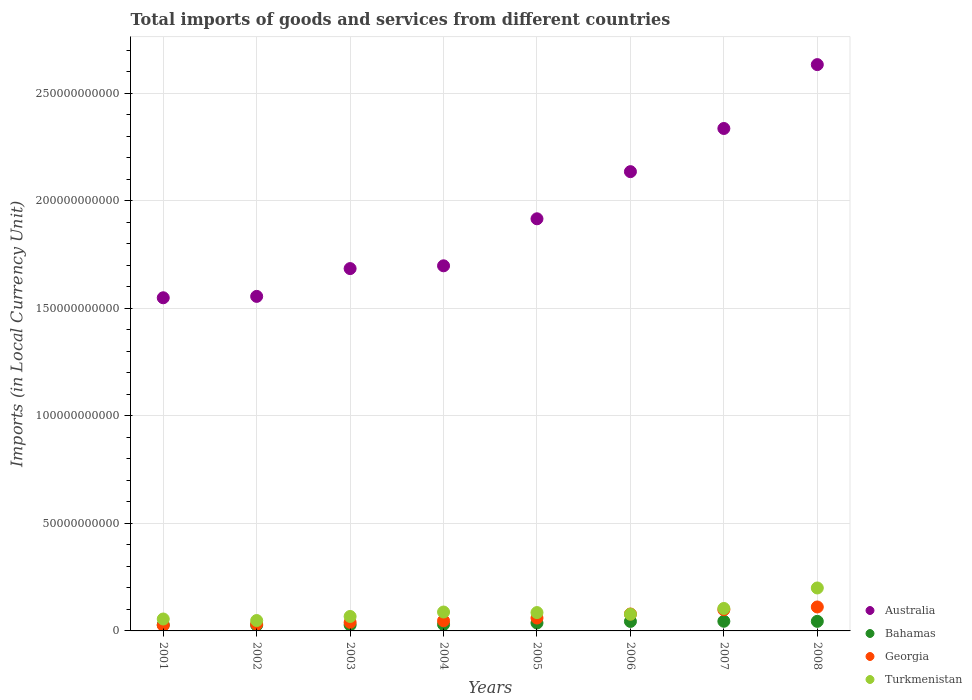What is the Amount of goods and services imports in Georgia in 2005?
Your answer should be very brief. 5.99e+09. Across all years, what is the maximum Amount of goods and services imports in Australia?
Give a very brief answer. 2.63e+11. Across all years, what is the minimum Amount of goods and services imports in Bahamas?
Your answer should be compact. 2.67e+09. In which year was the Amount of goods and services imports in Turkmenistan maximum?
Ensure brevity in your answer.  2008. What is the total Amount of goods and services imports in Georgia in the graph?
Your answer should be very brief. 4.93e+1. What is the difference between the Amount of goods and services imports in Australia in 2004 and that in 2005?
Provide a short and direct response. -2.19e+1. What is the difference between the Amount of goods and services imports in Australia in 2004 and the Amount of goods and services imports in Turkmenistan in 2008?
Your answer should be very brief. 1.50e+11. What is the average Amount of goods and services imports in Bahamas per year?
Offer a terse response. 3.54e+09. In the year 2007, what is the difference between the Amount of goods and services imports in Georgia and Amount of goods and services imports in Turkmenistan?
Ensure brevity in your answer.  -6.01e+08. What is the ratio of the Amount of goods and services imports in Australia in 2005 to that in 2008?
Provide a succinct answer. 0.73. Is the Amount of goods and services imports in Australia in 2002 less than that in 2008?
Keep it short and to the point. Yes. Is the difference between the Amount of goods and services imports in Georgia in 2004 and 2007 greater than the difference between the Amount of goods and services imports in Turkmenistan in 2004 and 2007?
Provide a short and direct response. No. What is the difference between the highest and the second highest Amount of goods and services imports in Bahamas?
Offer a very short reply. 3.76e+07. What is the difference between the highest and the lowest Amount of goods and services imports in Turkmenistan?
Make the answer very short. 1.51e+1. Is the Amount of goods and services imports in Turkmenistan strictly less than the Amount of goods and services imports in Bahamas over the years?
Make the answer very short. No. How many dotlines are there?
Your response must be concise. 4. How many years are there in the graph?
Offer a terse response. 8. Does the graph contain any zero values?
Your answer should be compact. No. Where does the legend appear in the graph?
Offer a terse response. Bottom right. How many legend labels are there?
Provide a short and direct response. 4. What is the title of the graph?
Your answer should be compact. Total imports of goods and services from different countries. What is the label or title of the X-axis?
Offer a terse response. Years. What is the label or title of the Y-axis?
Your answer should be compact. Imports (in Local Currency Unit). What is the Imports (in Local Currency Unit) of Australia in 2001?
Make the answer very short. 1.55e+11. What is the Imports (in Local Currency Unit) of Bahamas in 2001?
Provide a short and direct response. 2.82e+09. What is the Imports (in Local Currency Unit) of Georgia in 2001?
Offer a terse response. 2.59e+09. What is the Imports (in Local Currency Unit) in Turkmenistan in 2001?
Provide a short and direct response. 5.54e+09. What is the Imports (in Local Currency Unit) in Australia in 2002?
Your answer should be compact. 1.56e+11. What is the Imports (in Local Currency Unit) of Bahamas in 2002?
Your answer should be very brief. 2.67e+09. What is the Imports (in Local Currency Unit) of Georgia in 2002?
Provide a succinct answer. 3.16e+09. What is the Imports (in Local Currency Unit) of Turkmenistan in 2002?
Your answer should be compact. 4.83e+09. What is the Imports (in Local Currency Unit) in Australia in 2003?
Ensure brevity in your answer.  1.69e+11. What is the Imports (in Local Currency Unit) in Bahamas in 2003?
Provide a short and direct response. 2.76e+09. What is the Imports (in Local Currency Unit) of Georgia in 2003?
Offer a terse response. 3.98e+09. What is the Imports (in Local Currency Unit) in Turkmenistan in 2003?
Make the answer very short. 6.73e+09. What is the Imports (in Local Currency Unit) in Australia in 2004?
Your response must be concise. 1.70e+11. What is the Imports (in Local Currency Unit) in Bahamas in 2004?
Keep it short and to the point. 3.02e+09. What is the Imports (in Local Currency Unit) of Georgia in 2004?
Your response must be concise. 4.73e+09. What is the Imports (in Local Currency Unit) of Turkmenistan in 2004?
Your answer should be very brief. 8.79e+09. What is the Imports (in Local Currency Unit) in Australia in 2005?
Your response must be concise. 1.92e+11. What is the Imports (in Local Currency Unit) in Bahamas in 2005?
Provide a succinct answer. 3.70e+09. What is the Imports (in Local Currency Unit) in Georgia in 2005?
Your answer should be compact. 5.99e+09. What is the Imports (in Local Currency Unit) of Turkmenistan in 2005?
Offer a very short reply. 8.53e+09. What is the Imports (in Local Currency Unit) in Australia in 2006?
Keep it short and to the point. 2.14e+11. What is the Imports (in Local Currency Unit) in Bahamas in 2006?
Offer a very short reply. 4.42e+09. What is the Imports (in Local Currency Unit) in Georgia in 2006?
Your answer should be very brief. 7.86e+09. What is the Imports (in Local Currency Unit) of Turkmenistan in 2006?
Give a very brief answer. 7.77e+09. What is the Imports (in Local Currency Unit) of Australia in 2007?
Provide a succinct answer. 2.34e+11. What is the Imports (in Local Currency Unit) in Bahamas in 2007?
Provide a succinct answer. 4.49e+09. What is the Imports (in Local Currency Unit) in Georgia in 2007?
Provide a short and direct response. 9.85e+09. What is the Imports (in Local Currency Unit) of Turkmenistan in 2007?
Offer a terse response. 1.04e+1. What is the Imports (in Local Currency Unit) in Australia in 2008?
Your answer should be very brief. 2.63e+11. What is the Imports (in Local Currency Unit) in Bahamas in 2008?
Offer a very short reply. 4.45e+09. What is the Imports (in Local Currency Unit) in Georgia in 2008?
Your answer should be compact. 1.11e+1. What is the Imports (in Local Currency Unit) in Turkmenistan in 2008?
Provide a succinct answer. 2.00e+1. Across all years, what is the maximum Imports (in Local Currency Unit) of Australia?
Ensure brevity in your answer.  2.63e+11. Across all years, what is the maximum Imports (in Local Currency Unit) in Bahamas?
Keep it short and to the point. 4.49e+09. Across all years, what is the maximum Imports (in Local Currency Unit) in Georgia?
Offer a terse response. 1.11e+1. Across all years, what is the maximum Imports (in Local Currency Unit) in Turkmenistan?
Ensure brevity in your answer.  2.00e+1. Across all years, what is the minimum Imports (in Local Currency Unit) of Australia?
Make the answer very short. 1.55e+11. Across all years, what is the minimum Imports (in Local Currency Unit) in Bahamas?
Provide a short and direct response. 2.67e+09. Across all years, what is the minimum Imports (in Local Currency Unit) in Georgia?
Provide a short and direct response. 2.59e+09. Across all years, what is the minimum Imports (in Local Currency Unit) in Turkmenistan?
Your answer should be very brief. 4.83e+09. What is the total Imports (in Local Currency Unit) of Australia in the graph?
Your response must be concise. 1.55e+12. What is the total Imports (in Local Currency Unit) in Bahamas in the graph?
Your answer should be very brief. 2.83e+1. What is the total Imports (in Local Currency Unit) of Georgia in the graph?
Ensure brevity in your answer.  4.93e+1. What is the total Imports (in Local Currency Unit) in Turkmenistan in the graph?
Ensure brevity in your answer.  7.26e+1. What is the difference between the Imports (in Local Currency Unit) in Australia in 2001 and that in 2002?
Your answer should be very brief. -6.45e+08. What is the difference between the Imports (in Local Currency Unit) in Bahamas in 2001 and that in 2002?
Ensure brevity in your answer.  1.48e+08. What is the difference between the Imports (in Local Currency Unit) in Georgia in 2001 and that in 2002?
Provide a short and direct response. -5.67e+08. What is the difference between the Imports (in Local Currency Unit) in Turkmenistan in 2001 and that in 2002?
Make the answer very short. 7.11e+08. What is the difference between the Imports (in Local Currency Unit) of Australia in 2001 and that in 2003?
Provide a succinct answer. -1.36e+1. What is the difference between the Imports (in Local Currency Unit) of Bahamas in 2001 and that in 2003?
Provide a short and direct response. 6.12e+07. What is the difference between the Imports (in Local Currency Unit) in Georgia in 2001 and that in 2003?
Your answer should be compact. -1.38e+09. What is the difference between the Imports (in Local Currency Unit) in Turkmenistan in 2001 and that in 2003?
Give a very brief answer. -1.18e+09. What is the difference between the Imports (in Local Currency Unit) of Australia in 2001 and that in 2004?
Ensure brevity in your answer.  -1.49e+1. What is the difference between the Imports (in Local Currency Unit) of Bahamas in 2001 and that in 2004?
Your response must be concise. -1.99e+08. What is the difference between the Imports (in Local Currency Unit) in Georgia in 2001 and that in 2004?
Your answer should be compact. -2.14e+09. What is the difference between the Imports (in Local Currency Unit) of Turkmenistan in 2001 and that in 2004?
Your response must be concise. -3.25e+09. What is the difference between the Imports (in Local Currency Unit) in Australia in 2001 and that in 2005?
Your response must be concise. -3.67e+1. What is the difference between the Imports (in Local Currency Unit) in Bahamas in 2001 and that in 2005?
Give a very brief answer. -8.80e+08. What is the difference between the Imports (in Local Currency Unit) in Georgia in 2001 and that in 2005?
Keep it short and to the point. -3.40e+09. What is the difference between the Imports (in Local Currency Unit) of Turkmenistan in 2001 and that in 2005?
Your answer should be very brief. -2.99e+09. What is the difference between the Imports (in Local Currency Unit) of Australia in 2001 and that in 2006?
Ensure brevity in your answer.  -5.87e+1. What is the difference between the Imports (in Local Currency Unit) in Bahamas in 2001 and that in 2006?
Offer a very short reply. -1.60e+09. What is the difference between the Imports (in Local Currency Unit) in Georgia in 2001 and that in 2006?
Your response must be concise. -5.27e+09. What is the difference between the Imports (in Local Currency Unit) of Turkmenistan in 2001 and that in 2006?
Your answer should be very brief. -2.23e+09. What is the difference between the Imports (in Local Currency Unit) in Australia in 2001 and that in 2007?
Make the answer very short. -7.87e+1. What is the difference between the Imports (in Local Currency Unit) in Bahamas in 2001 and that in 2007?
Make the answer very short. -1.67e+09. What is the difference between the Imports (in Local Currency Unit) of Georgia in 2001 and that in 2007?
Your response must be concise. -7.25e+09. What is the difference between the Imports (in Local Currency Unit) in Turkmenistan in 2001 and that in 2007?
Offer a very short reply. -4.91e+09. What is the difference between the Imports (in Local Currency Unit) in Australia in 2001 and that in 2008?
Your response must be concise. -1.08e+11. What is the difference between the Imports (in Local Currency Unit) of Bahamas in 2001 and that in 2008?
Offer a very short reply. -1.63e+09. What is the difference between the Imports (in Local Currency Unit) in Georgia in 2001 and that in 2008?
Provide a succinct answer. -8.55e+09. What is the difference between the Imports (in Local Currency Unit) in Turkmenistan in 2001 and that in 2008?
Offer a very short reply. -1.44e+1. What is the difference between the Imports (in Local Currency Unit) in Australia in 2002 and that in 2003?
Your answer should be compact. -1.29e+1. What is the difference between the Imports (in Local Currency Unit) in Bahamas in 2002 and that in 2003?
Provide a short and direct response. -8.67e+07. What is the difference between the Imports (in Local Currency Unit) in Georgia in 2002 and that in 2003?
Make the answer very short. -8.14e+08. What is the difference between the Imports (in Local Currency Unit) in Turkmenistan in 2002 and that in 2003?
Ensure brevity in your answer.  -1.89e+09. What is the difference between the Imports (in Local Currency Unit) of Australia in 2002 and that in 2004?
Your answer should be very brief. -1.42e+1. What is the difference between the Imports (in Local Currency Unit) in Bahamas in 2002 and that in 2004?
Your answer should be very brief. -3.47e+08. What is the difference between the Imports (in Local Currency Unit) in Georgia in 2002 and that in 2004?
Offer a very short reply. -1.57e+09. What is the difference between the Imports (in Local Currency Unit) of Turkmenistan in 2002 and that in 2004?
Ensure brevity in your answer.  -3.96e+09. What is the difference between the Imports (in Local Currency Unit) of Australia in 2002 and that in 2005?
Provide a succinct answer. -3.61e+1. What is the difference between the Imports (in Local Currency Unit) of Bahamas in 2002 and that in 2005?
Your answer should be very brief. -1.03e+09. What is the difference between the Imports (in Local Currency Unit) in Georgia in 2002 and that in 2005?
Give a very brief answer. -2.83e+09. What is the difference between the Imports (in Local Currency Unit) in Turkmenistan in 2002 and that in 2005?
Give a very brief answer. -3.70e+09. What is the difference between the Imports (in Local Currency Unit) in Australia in 2002 and that in 2006?
Offer a very short reply. -5.80e+1. What is the difference between the Imports (in Local Currency Unit) in Bahamas in 2002 and that in 2006?
Provide a succinct answer. -1.74e+09. What is the difference between the Imports (in Local Currency Unit) in Georgia in 2002 and that in 2006?
Ensure brevity in your answer.  -4.70e+09. What is the difference between the Imports (in Local Currency Unit) of Turkmenistan in 2002 and that in 2006?
Provide a succinct answer. -2.94e+09. What is the difference between the Imports (in Local Currency Unit) in Australia in 2002 and that in 2007?
Make the answer very short. -7.81e+1. What is the difference between the Imports (in Local Currency Unit) in Bahamas in 2002 and that in 2007?
Offer a very short reply. -1.82e+09. What is the difference between the Imports (in Local Currency Unit) in Georgia in 2002 and that in 2007?
Your answer should be compact. -6.69e+09. What is the difference between the Imports (in Local Currency Unit) in Turkmenistan in 2002 and that in 2007?
Your response must be concise. -5.62e+09. What is the difference between the Imports (in Local Currency Unit) of Australia in 2002 and that in 2008?
Provide a short and direct response. -1.08e+11. What is the difference between the Imports (in Local Currency Unit) of Bahamas in 2002 and that in 2008?
Keep it short and to the point. -1.78e+09. What is the difference between the Imports (in Local Currency Unit) of Georgia in 2002 and that in 2008?
Your answer should be compact. -7.98e+09. What is the difference between the Imports (in Local Currency Unit) in Turkmenistan in 2002 and that in 2008?
Your answer should be compact. -1.51e+1. What is the difference between the Imports (in Local Currency Unit) in Australia in 2003 and that in 2004?
Offer a terse response. -1.29e+09. What is the difference between the Imports (in Local Currency Unit) in Bahamas in 2003 and that in 2004?
Your response must be concise. -2.60e+08. What is the difference between the Imports (in Local Currency Unit) of Georgia in 2003 and that in 2004?
Keep it short and to the point. -7.58e+08. What is the difference between the Imports (in Local Currency Unit) in Turkmenistan in 2003 and that in 2004?
Ensure brevity in your answer.  -2.06e+09. What is the difference between the Imports (in Local Currency Unit) of Australia in 2003 and that in 2005?
Make the answer very short. -2.32e+1. What is the difference between the Imports (in Local Currency Unit) of Bahamas in 2003 and that in 2005?
Ensure brevity in your answer.  -9.41e+08. What is the difference between the Imports (in Local Currency Unit) of Georgia in 2003 and that in 2005?
Your answer should be compact. -2.02e+09. What is the difference between the Imports (in Local Currency Unit) of Turkmenistan in 2003 and that in 2005?
Make the answer very short. -1.81e+09. What is the difference between the Imports (in Local Currency Unit) of Australia in 2003 and that in 2006?
Make the answer very short. -4.51e+1. What is the difference between the Imports (in Local Currency Unit) in Bahamas in 2003 and that in 2006?
Keep it short and to the point. -1.66e+09. What is the difference between the Imports (in Local Currency Unit) in Georgia in 2003 and that in 2006?
Offer a very short reply. -3.89e+09. What is the difference between the Imports (in Local Currency Unit) of Turkmenistan in 2003 and that in 2006?
Offer a terse response. -1.04e+09. What is the difference between the Imports (in Local Currency Unit) of Australia in 2003 and that in 2007?
Make the answer very short. -6.52e+1. What is the difference between the Imports (in Local Currency Unit) of Bahamas in 2003 and that in 2007?
Your response must be concise. -1.73e+09. What is the difference between the Imports (in Local Currency Unit) of Georgia in 2003 and that in 2007?
Give a very brief answer. -5.87e+09. What is the difference between the Imports (in Local Currency Unit) in Turkmenistan in 2003 and that in 2007?
Your response must be concise. -3.72e+09. What is the difference between the Imports (in Local Currency Unit) of Australia in 2003 and that in 2008?
Offer a very short reply. -9.49e+1. What is the difference between the Imports (in Local Currency Unit) of Bahamas in 2003 and that in 2008?
Ensure brevity in your answer.  -1.69e+09. What is the difference between the Imports (in Local Currency Unit) of Georgia in 2003 and that in 2008?
Offer a terse response. -7.16e+09. What is the difference between the Imports (in Local Currency Unit) in Turkmenistan in 2003 and that in 2008?
Your answer should be very brief. -1.32e+1. What is the difference between the Imports (in Local Currency Unit) of Australia in 2004 and that in 2005?
Make the answer very short. -2.19e+1. What is the difference between the Imports (in Local Currency Unit) in Bahamas in 2004 and that in 2005?
Ensure brevity in your answer.  -6.81e+08. What is the difference between the Imports (in Local Currency Unit) in Georgia in 2004 and that in 2005?
Ensure brevity in your answer.  -1.26e+09. What is the difference between the Imports (in Local Currency Unit) of Turkmenistan in 2004 and that in 2005?
Ensure brevity in your answer.  2.55e+08. What is the difference between the Imports (in Local Currency Unit) in Australia in 2004 and that in 2006?
Your answer should be very brief. -4.38e+1. What is the difference between the Imports (in Local Currency Unit) in Bahamas in 2004 and that in 2006?
Offer a very short reply. -1.40e+09. What is the difference between the Imports (in Local Currency Unit) of Georgia in 2004 and that in 2006?
Offer a very short reply. -3.13e+09. What is the difference between the Imports (in Local Currency Unit) in Turkmenistan in 2004 and that in 2006?
Ensure brevity in your answer.  1.02e+09. What is the difference between the Imports (in Local Currency Unit) of Australia in 2004 and that in 2007?
Ensure brevity in your answer.  -6.39e+1. What is the difference between the Imports (in Local Currency Unit) in Bahamas in 2004 and that in 2007?
Your answer should be compact. -1.47e+09. What is the difference between the Imports (in Local Currency Unit) in Georgia in 2004 and that in 2007?
Keep it short and to the point. -5.11e+09. What is the difference between the Imports (in Local Currency Unit) of Turkmenistan in 2004 and that in 2007?
Offer a very short reply. -1.66e+09. What is the difference between the Imports (in Local Currency Unit) in Australia in 2004 and that in 2008?
Your answer should be compact. -9.36e+1. What is the difference between the Imports (in Local Currency Unit) of Bahamas in 2004 and that in 2008?
Keep it short and to the point. -1.43e+09. What is the difference between the Imports (in Local Currency Unit) of Georgia in 2004 and that in 2008?
Offer a very short reply. -6.41e+09. What is the difference between the Imports (in Local Currency Unit) in Turkmenistan in 2004 and that in 2008?
Provide a short and direct response. -1.12e+1. What is the difference between the Imports (in Local Currency Unit) in Australia in 2005 and that in 2006?
Keep it short and to the point. -2.19e+1. What is the difference between the Imports (in Local Currency Unit) in Bahamas in 2005 and that in 2006?
Ensure brevity in your answer.  -7.17e+08. What is the difference between the Imports (in Local Currency Unit) of Georgia in 2005 and that in 2006?
Give a very brief answer. -1.87e+09. What is the difference between the Imports (in Local Currency Unit) in Turkmenistan in 2005 and that in 2006?
Your answer should be compact. 7.64e+08. What is the difference between the Imports (in Local Currency Unit) of Australia in 2005 and that in 2007?
Provide a short and direct response. -4.20e+1. What is the difference between the Imports (in Local Currency Unit) of Bahamas in 2005 and that in 2007?
Provide a succinct answer. -7.89e+08. What is the difference between the Imports (in Local Currency Unit) in Georgia in 2005 and that in 2007?
Your answer should be compact. -3.86e+09. What is the difference between the Imports (in Local Currency Unit) in Turkmenistan in 2005 and that in 2007?
Ensure brevity in your answer.  -1.92e+09. What is the difference between the Imports (in Local Currency Unit) in Australia in 2005 and that in 2008?
Offer a very short reply. -7.17e+1. What is the difference between the Imports (in Local Currency Unit) in Bahamas in 2005 and that in 2008?
Your response must be concise. -7.52e+08. What is the difference between the Imports (in Local Currency Unit) in Georgia in 2005 and that in 2008?
Keep it short and to the point. -5.15e+09. What is the difference between the Imports (in Local Currency Unit) of Turkmenistan in 2005 and that in 2008?
Your answer should be compact. -1.14e+1. What is the difference between the Imports (in Local Currency Unit) in Australia in 2006 and that in 2007?
Your response must be concise. -2.01e+1. What is the difference between the Imports (in Local Currency Unit) in Bahamas in 2006 and that in 2007?
Make the answer very short. -7.22e+07. What is the difference between the Imports (in Local Currency Unit) in Georgia in 2006 and that in 2007?
Your answer should be compact. -1.99e+09. What is the difference between the Imports (in Local Currency Unit) in Turkmenistan in 2006 and that in 2007?
Make the answer very short. -2.68e+09. What is the difference between the Imports (in Local Currency Unit) in Australia in 2006 and that in 2008?
Give a very brief answer. -4.98e+1. What is the difference between the Imports (in Local Currency Unit) in Bahamas in 2006 and that in 2008?
Provide a succinct answer. -3.46e+07. What is the difference between the Imports (in Local Currency Unit) in Georgia in 2006 and that in 2008?
Give a very brief answer. -3.28e+09. What is the difference between the Imports (in Local Currency Unit) of Turkmenistan in 2006 and that in 2008?
Your answer should be compact. -1.22e+1. What is the difference between the Imports (in Local Currency Unit) of Australia in 2007 and that in 2008?
Provide a succinct answer. -2.97e+1. What is the difference between the Imports (in Local Currency Unit) of Bahamas in 2007 and that in 2008?
Your answer should be compact. 3.76e+07. What is the difference between the Imports (in Local Currency Unit) of Georgia in 2007 and that in 2008?
Keep it short and to the point. -1.29e+09. What is the difference between the Imports (in Local Currency Unit) of Turkmenistan in 2007 and that in 2008?
Your answer should be compact. -9.52e+09. What is the difference between the Imports (in Local Currency Unit) in Australia in 2001 and the Imports (in Local Currency Unit) in Bahamas in 2002?
Keep it short and to the point. 1.52e+11. What is the difference between the Imports (in Local Currency Unit) of Australia in 2001 and the Imports (in Local Currency Unit) of Georgia in 2002?
Your answer should be very brief. 1.52e+11. What is the difference between the Imports (in Local Currency Unit) in Australia in 2001 and the Imports (in Local Currency Unit) in Turkmenistan in 2002?
Offer a very short reply. 1.50e+11. What is the difference between the Imports (in Local Currency Unit) of Bahamas in 2001 and the Imports (in Local Currency Unit) of Georgia in 2002?
Give a very brief answer. -3.41e+08. What is the difference between the Imports (in Local Currency Unit) in Bahamas in 2001 and the Imports (in Local Currency Unit) in Turkmenistan in 2002?
Your answer should be compact. -2.01e+09. What is the difference between the Imports (in Local Currency Unit) of Georgia in 2001 and the Imports (in Local Currency Unit) of Turkmenistan in 2002?
Offer a terse response. -2.24e+09. What is the difference between the Imports (in Local Currency Unit) of Australia in 2001 and the Imports (in Local Currency Unit) of Bahamas in 2003?
Your answer should be compact. 1.52e+11. What is the difference between the Imports (in Local Currency Unit) in Australia in 2001 and the Imports (in Local Currency Unit) in Georgia in 2003?
Ensure brevity in your answer.  1.51e+11. What is the difference between the Imports (in Local Currency Unit) of Australia in 2001 and the Imports (in Local Currency Unit) of Turkmenistan in 2003?
Provide a short and direct response. 1.48e+11. What is the difference between the Imports (in Local Currency Unit) of Bahamas in 2001 and the Imports (in Local Currency Unit) of Georgia in 2003?
Keep it short and to the point. -1.16e+09. What is the difference between the Imports (in Local Currency Unit) in Bahamas in 2001 and the Imports (in Local Currency Unit) in Turkmenistan in 2003?
Your answer should be compact. -3.91e+09. What is the difference between the Imports (in Local Currency Unit) of Georgia in 2001 and the Imports (in Local Currency Unit) of Turkmenistan in 2003?
Give a very brief answer. -4.13e+09. What is the difference between the Imports (in Local Currency Unit) of Australia in 2001 and the Imports (in Local Currency Unit) of Bahamas in 2004?
Your response must be concise. 1.52e+11. What is the difference between the Imports (in Local Currency Unit) in Australia in 2001 and the Imports (in Local Currency Unit) in Georgia in 2004?
Your answer should be compact. 1.50e+11. What is the difference between the Imports (in Local Currency Unit) in Australia in 2001 and the Imports (in Local Currency Unit) in Turkmenistan in 2004?
Your answer should be very brief. 1.46e+11. What is the difference between the Imports (in Local Currency Unit) in Bahamas in 2001 and the Imports (in Local Currency Unit) in Georgia in 2004?
Make the answer very short. -1.91e+09. What is the difference between the Imports (in Local Currency Unit) of Bahamas in 2001 and the Imports (in Local Currency Unit) of Turkmenistan in 2004?
Provide a short and direct response. -5.97e+09. What is the difference between the Imports (in Local Currency Unit) of Georgia in 2001 and the Imports (in Local Currency Unit) of Turkmenistan in 2004?
Keep it short and to the point. -6.20e+09. What is the difference between the Imports (in Local Currency Unit) of Australia in 2001 and the Imports (in Local Currency Unit) of Bahamas in 2005?
Keep it short and to the point. 1.51e+11. What is the difference between the Imports (in Local Currency Unit) of Australia in 2001 and the Imports (in Local Currency Unit) of Georgia in 2005?
Make the answer very short. 1.49e+11. What is the difference between the Imports (in Local Currency Unit) of Australia in 2001 and the Imports (in Local Currency Unit) of Turkmenistan in 2005?
Keep it short and to the point. 1.46e+11. What is the difference between the Imports (in Local Currency Unit) of Bahamas in 2001 and the Imports (in Local Currency Unit) of Georgia in 2005?
Make the answer very short. -3.17e+09. What is the difference between the Imports (in Local Currency Unit) of Bahamas in 2001 and the Imports (in Local Currency Unit) of Turkmenistan in 2005?
Provide a succinct answer. -5.71e+09. What is the difference between the Imports (in Local Currency Unit) of Georgia in 2001 and the Imports (in Local Currency Unit) of Turkmenistan in 2005?
Make the answer very short. -5.94e+09. What is the difference between the Imports (in Local Currency Unit) of Australia in 2001 and the Imports (in Local Currency Unit) of Bahamas in 2006?
Your answer should be compact. 1.51e+11. What is the difference between the Imports (in Local Currency Unit) in Australia in 2001 and the Imports (in Local Currency Unit) in Georgia in 2006?
Provide a succinct answer. 1.47e+11. What is the difference between the Imports (in Local Currency Unit) of Australia in 2001 and the Imports (in Local Currency Unit) of Turkmenistan in 2006?
Your answer should be very brief. 1.47e+11. What is the difference between the Imports (in Local Currency Unit) of Bahamas in 2001 and the Imports (in Local Currency Unit) of Georgia in 2006?
Keep it short and to the point. -5.04e+09. What is the difference between the Imports (in Local Currency Unit) of Bahamas in 2001 and the Imports (in Local Currency Unit) of Turkmenistan in 2006?
Your answer should be compact. -4.95e+09. What is the difference between the Imports (in Local Currency Unit) in Georgia in 2001 and the Imports (in Local Currency Unit) in Turkmenistan in 2006?
Your response must be concise. -5.18e+09. What is the difference between the Imports (in Local Currency Unit) in Australia in 2001 and the Imports (in Local Currency Unit) in Bahamas in 2007?
Give a very brief answer. 1.50e+11. What is the difference between the Imports (in Local Currency Unit) of Australia in 2001 and the Imports (in Local Currency Unit) of Georgia in 2007?
Provide a succinct answer. 1.45e+11. What is the difference between the Imports (in Local Currency Unit) of Australia in 2001 and the Imports (in Local Currency Unit) of Turkmenistan in 2007?
Your response must be concise. 1.44e+11. What is the difference between the Imports (in Local Currency Unit) in Bahamas in 2001 and the Imports (in Local Currency Unit) in Georgia in 2007?
Offer a very short reply. -7.03e+09. What is the difference between the Imports (in Local Currency Unit) in Bahamas in 2001 and the Imports (in Local Currency Unit) in Turkmenistan in 2007?
Your response must be concise. -7.63e+09. What is the difference between the Imports (in Local Currency Unit) in Georgia in 2001 and the Imports (in Local Currency Unit) in Turkmenistan in 2007?
Offer a terse response. -7.85e+09. What is the difference between the Imports (in Local Currency Unit) of Australia in 2001 and the Imports (in Local Currency Unit) of Bahamas in 2008?
Provide a succinct answer. 1.50e+11. What is the difference between the Imports (in Local Currency Unit) in Australia in 2001 and the Imports (in Local Currency Unit) in Georgia in 2008?
Keep it short and to the point. 1.44e+11. What is the difference between the Imports (in Local Currency Unit) of Australia in 2001 and the Imports (in Local Currency Unit) of Turkmenistan in 2008?
Offer a terse response. 1.35e+11. What is the difference between the Imports (in Local Currency Unit) in Bahamas in 2001 and the Imports (in Local Currency Unit) in Georgia in 2008?
Ensure brevity in your answer.  -8.32e+09. What is the difference between the Imports (in Local Currency Unit) in Bahamas in 2001 and the Imports (in Local Currency Unit) in Turkmenistan in 2008?
Make the answer very short. -1.72e+1. What is the difference between the Imports (in Local Currency Unit) in Georgia in 2001 and the Imports (in Local Currency Unit) in Turkmenistan in 2008?
Ensure brevity in your answer.  -1.74e+1. What is the difference between the Imports (in Local Currency Unit) in Australia in 2002 and the Imports (in Local Currency Unit) in Bahamas in 2003?
Make the answer very short. 1.53e+11. What is the difference between the Imports (in Local Currency Unit) in Australia in 2002 and the Imports (in Local Currency Unit) in Georgia in 2003?
Your answer should be compact. 1.52e+11. What is the difference between the Imports (in Local Currency Unit) of Australia in 2002 and the Imports (in Local Currency Unit) of Turkmenistan in 2003?
Your response must be concise. 1.49e+11. What is the difference between the Imports (in Local Currency Unit) in Bahamas in 2002 and the Imports (in Local Currency Unit) in Georgia in 2003?
Give a very brief answer. -1.30e+09. What is the difference between the Imports (in Local Currency Unit) of Bahamas in 2002 and the Imports (in Local Currency Unit) of Turkmenistan in 2003?
Make the answer very short. -4.05e+09. What is the difference between the Imports (in Local Currency Unit) in Georgia in 2002 and the Imports (in Local Currency Unit) in Turkmenistan in 2003?
Offer a terse response. -3.56e+09. What is the difference between the Imports (in Local Currency Unit) of Australia in 2002 and the Imports (in Local Currency Unit) of Bahamas in 2004?
Provide a short and direct response. 1.53e+11. What is the difference between the Imports (in Local Currency Unit) of Australia in 2002 and the Imports (in Local Currency Unit) of Georgia in 2004?
Your answer should be compact. 1.51e+11. What is the difference between the Imports (in Local Currency Unit) of Australia in 2002 and the Imports (in Local Currency Unit) of Turkmenistan in 2004?
Give a very brief answer. 1.47e+11. What is the difference between the Imports (in Local Currency Unit) in Bahamas in 2002 and the Imports (in Local Currency Unit) in Georgia in 2004?
Provide a succinct answer. -2.06e+09. What is the difference between the Imports (in Local Currency Unit) of Bahamas in 2002 and the Imports (in Local Currency Unit) of Turkmenistan in 2004?
Provide a short and direct response. -6.12e+09. What is the difference between the Imports (in Local Currency Unit) of Georgia in 2002 and the Imports (in Local Currency Unit) of Turkmenistan in 2004?
Give a very brief answer. -5.63e+09. What is the difference between the Imports (in Local Currency Unit) of Australia in 2002 and the Imports (in Local Currency Unit) of Bahamas in 2005?
Keep it short and to the point. 1.52e+11. What is the difference between the Imports (in Local Currency Unit) of Australia in 2002 and the Imports (in Local Currency Unit) of Georgia in 2005?
Your answer should be very brief. 1.50e+11. What is the difference between the Imports (in Local Currency Unit) in Australia in 2002 and the Imports (in Local Currency Unit) in Turkmenistan in 2005?
Make the answer very short. 1.47e+11. What is the difference between the Imports (in Local Currency Unit) of Bahamas in 2002 and the Imports (in Local Currency Unit) of Georgia in 2005?
Offer a terse response. -3.32e+09. What is the difference between the Imports (in Local Currency Unit) of Bahamas in 2002 and the Imports (in Local Currency Unit) of Turkmenistan in 2005?
Your response must be concise. -5.86e+09. What is the difference between the Imports (in Local Currency Unit) in Georgia in 2002 and the Imports (in Local Currency Unit) in Turkmenistan in 2005?
Provide a short and direct response. -5.37e+09. What is the difference between the Imports (in Local Currency Unit) of Australia in 2002 and the Imports (in Local Currency Unit) of Bahamas in 2006?
Keep it short and to the point. 1.51e+11. What is the difference between the Imports (in Local Currency Unit) of Australia in 2002 and the Imports (in Local Currency Unit) of Georgia in 2006?
Give a very brief answer. 1.48e+11. What is the difference between the Imports (in Local Currency Unit) in Australia in 2002 and the Imports (in Local Currency Unit) in Turkmenistan in 2006?
Keep it short and to the point. 1.48e+11. What is the difference between the Imports (in Local Currency Unit) in Bahamas in 2002 and the Imports (in Local Currency Unit) in Georgia in 2006?
Offer a terse response. -5.19e+09. What is the difference between the Imports (in Local Currency Unit) in Bahamas in 2002 and the Imports (in Local Currency Unit) in Turkmenistan in 2006?
Offer a very short reply. -5.10e+09. What is the difference between the Imports (in Local Currency Unit) of Georgia in 2002 and the Imports (in Local Currency Unit) of Turkmenistan in 2006?
Ensure brevity in your answer.  -4.61e+09. What is the difference between the Imports (in Local Currency Unit) of Australia in 2002 and the Imports (in Local Currency Unit) of Bahamas in 2007?
Offer a very short reply. 1.51e+11. What is the difference between the Imports (in Local Currency Unit) in Australia in 2002 and the Imports (in Local Currency Unit) in Georgia in 2007?
Offer a very short reply. 1.46e+11. What is the difference between the Imports (in Local Currency Unit) in Australia in 2002 and the Imports (in Local Currency Unit) in Turkmenistan in 2007?
Give a very brief answer. 1.45e+11. What is the difference between the Imports (in Local Currency Unit) in Bahamas in 2002 and the Imports (in Local Currency Unit) in Georgia in 2007?
Ensure brevity in your answer.  -7.18e+09. What is the difference between the Imports (in Local Currency Unit) in Bahamas in 2002 and the Imports (in Local Currency Unit) in Turkmenistan in 2007?
Ensure brevity in your answer.  -7.78e+09. What is the difference between the Imports (in Local Currency Unit) of Georgia in 2002 and the Imports (in Local Currency Unit) of Turkmenistan in 2007?
Make the answer very short. -7.29e+09. What is the difference between the Imports (in Local Currency Unit) in Australia in 2002 and the Imports (in Local Currency Unit) in Bahamas in 2008?
Provide a succinct answer. 1.51e+11. What is the difference between the Imports (in Local Currency Unit) of Australia in 2002 and the Imports (in Local Currency Unit) of Georgia in 2008?
Offer a terse response. 1.44e+11. What is the difference between the Imports (in Local Currency Unit) in Australia in 2002 and the Imports (in Local Currency Unit) in Turkmenistan in 2008?
Provide a succinct answer. 1.36e+11. What is the difference between the Imports (in Local Currency Unit) in Bahamas in 2002 and the Imports (in Local Currency Unit) in Georgia in 2008?
Give a very brief answer. -8.47e+09. What is the difference between the Imports (in Local Currency Unit) of Bahamas in 2002 and the Imports (in Local Currency Unit) of Turkmenistan in 2008?
Offer a terse response. -1.73e+1. What is the difference between the Imports (in Local Currency Unit) of Georgia in 2002 and the Imports (in Local Currency Unit) of Turkmenistan in 2008?
Provide a succinct answer. -1.68e+1. What is the difference between the Imports (in Local Currency Unit) in Australia in 2003 and the Imports (in Local Currency Unit) in Bahamas in 2004?
Your answer should be very brief. 1.65e+11. What is the difference between the Imports (in Local Currency Unit) in Australia in 2003 and the Imports (in Local Currency Unit) in Georgia in 2004?
Ensure brevity in your answer.  1.64e+11. What is the difference between the Imports (in Local Currency Unit) of Australia in 2003 and the Imports (in Local Currency Unit) of Turkmenistan in 2004?
Offer a very short reply. 1.60e+11. What is the difference between the Imports (in Local Currency Unit) in Bahamas in 2003 and the Imports (in Local Currency Unit) in Georgia in 2004?
Make the answer very short. -1.97e+09. What is the difference between the Imports (in Local Currency Unit) of Bahamas in 2003 and the Imports (in Local Currency Unit) of Turkmenistan in 2004?
Offer a very short reply. -6.03e+09. What is the difference between the Imports (in Local Currency Unit) in Georgia in 2003 and the Imports (in Local Currency Unit) in Turkmenistan in 2004?
Your response must be concise. -4.81e+09. What is the difference between the Imports (in Local Currency Unit) of Australia in 2003 and the Imports (in Local Currency Unit) of Bahamas in 2005?
Provide a succinct answer. 1.65e+11. What is the difference between the Imports (in Local Currency Unit) in Australia in 2003 and the Imports (in Local Currency Unit) in Georgia in 2005?
Make the answer very short. 1.63e+11. What is the difference between the Imports (in Local Currency Unit) in Australia in 2003 and the Imports (in Local Currency Unit) in Turkmenistan in 2005?
Provide a short and direct response. 1.60e+11. What is the difference between the Imports (in Local Currency Unit) in Bahamas in 2003 and the Imports (in Local Currency Unit) in Georgia in 2005?
Offer a very short reply. -3.23e+09. What is the difference between the Imports (in Local Currency Unit) in Bahamas in 2003 and the Imports (in Local Currency Unit) in Turkmenistan in 2005?
Provide a succinct answer. -5.78e+09. What is the difference between the Imports (in Local Currency Unit) of Georgia in 2003 and the Imports (in Local Currency Unit) of Turkmenistan in 2005?
Make the answer very short. -4.56e+09. What is the difference between the Imports (in Local Currency Unit) of Australia in 2003 and the Imports (in Local Currency Unit) of Bahamas in 2006?
Keep it short and to the point. 1.64e+11. What is the difference between the Imports (in Local Currency Unit) of Australia in 2003 and the Imports (in Local Currency Unit) of Georgia in 2006?
Offer a terse response. 1.61e+11. What is the difference between the Imports (in Local Currency Unit) of Australia in 2003 and the Imports (in Local Currency Unit) of Turkmenistan in 2006?
Provide a succinct answer. 1.61e+11. What is the difference between the Imports (in Local Currency Unit) in Bahamas in 2003 and the Imports (in Local Currency Unit) in Georgia in 2006?
Ensure brevity in your answer.  -5.10e+09. What is the difference between the Imports (in Local Currency Unit) in Bahamas in 2003 and the Imports (in Local Currency Unit) in Turkmenistan in 2006?
Ensure brevity in your answer.  -5.01e+09. What is the difference between the Imports (in Local Currency Unit) in Georgia in 2003 and the Imports (in Local Currency Unit) in Turkmenistan in 2006?
Give a very brief answer. -3.79e+09. What is the difference between the Imports (in Local Currency Unit) of Australia in 2003 and the Imports (in Local Currency Unit) of Bahamas in 2007?
Provide a succinct answer. 1.64e+11. What is the difference between the Imports (in Local Currency Unit) in Australia in 2003 and the Imports (in Local Currency Unit) in Georgia in 2007?
Give a very brief answer. 1.59e+11. What is the difference between the Imports (in Local Currency Unit) in Australia in 2003 and the Imports (in Local Currency Unit) in Turkmenistan in 2007?
Provide a succinct answer. 1.58e+11. What is the difference between the Imports (in Local Currency Unit) of Bahamas in 2003 and the Imports (in Local Currency Unit) of Georgia in 2007?
Make the answer very short. -7.09e+09. What is the difference between the Imports (in Local Currency Unit) of Bahamas in 2003 and the Imports (in Local Currency Unit) of Turkmenistan in 2007?
Offer a terse response. -7.69e+09. What is the difference between the Imports (in Local Currency Unit) of Georgia in 2003 and the Imports (in Local Currency Unit) of Turkmenistan in 2007?
Give a very brief answer. -6.47e+09. What is the difference between the Imports (in Local Currency Unit) in Australia in 2003 and the Imports (in Local Currency Unit) in Bahamas in 2008?
Offer a terse response. 1.64e+11. What is the difference between the Imports (in Local Currency Unit) in Australia in 2003 and the Imports (in Local Currency Unit) in Georgia in 2008?
Give a very brief answer. 1.57e+11. What is the difference between the Imports (in Local Currency Unit) of Australia in 2003 and the Imports (in Local Currency Unit) of Turkmenistan in 2008?
Make the answer very short. 1.49e+11. What is the difference between the Imports (in Local Currency Unit) of Bahamas in 2003 and the Imports (in Local Currency Unit) of Georgia in 2008?
Offer a very short reply. -8.38e+09. What is the difference between the Imports (in Local Currency Unit) in Bahamas in 2003 and the Imports (in Local Currency Unit) in Turkmenistan in 2008?
Offer a terse response. -1.72e+1. What is the difference between the Imports (in Local Currency Unit) of Georgia in 2003 and the Imports (in Local Currency Unit) of Turkmenistan in 2008?
Offer a terse response. -1.60e+1. What is the difference between the Imports (in Local Currency Unit) in Australia in 2004 and the Imports (in Local Currency Unit) in Bahamas in 2005?
Your response must be concise. 1.66e+11. What is the difference between the Imports (in Local Currency Unit) in Australia in 2004 and the Imports (in Local Currency Unit) in Georgia in 2005?
Make the answer very short. 1.64e+11. What is the difference between the Imports (in Local Currency Unit) in Australia in 2004 and the Imports (in Local Currency Unit) in Turkmenistan in 2005?
Provide a succinct answer. 1.61e+11. What is the difference between the Imports (in Local Currency Unit) of Bahamas in 2004 and the Imports (in Local Currency Unit) of Georgia in 2005?
Ensure brevity in your answer.  -2.97e+09. What is the difference between the Imports (in Local Currency Unit) in Bahamas in 2004 and the Imports (in Local Currency Unit) in Turkmenistan in 2005?
Give a very brief answer. -5.51e+09. What is the difference between the Imports (in Local Currency Unit) in Georgia in 2004 and the Imports (in Local Currency Unit) in Turkmenistan in 2005?
Your answer should be compact. -3.80e+09. What is the difference between the Imports (in Local Currency Unit) in Australia in 2004 and the Imports (in Local Currency Unit) in Bahamas in 2006?
Ensure brevity in your answer.  1.65e+11. What is the difference between the Imports (in Local Currency Unit) of Australia in 2004 and the Imports (in Local Currency Unit) of Georgia in 2006?
Give a very brief answer. 1.62e+11. What is the difference between the Imports (in Local Currency Unit) of Australia in 2004 and the Imports (in Local Currency Unit) of Turkmenistan in 2006?
Your answer should be compact. 1.62e+11. What is the difference between the Imports (in Local Currency Unit) of Bahamas in 2004 and the Imports (in Local Currency Unit) of Georgia in 2006?
Your answer should be compact. -4.84e+09. What is the difference between the Imports (in Local Currency Unit) of Bahamas in 2004 and the Imports (in Local Currency Unit) of Turkmenistan in 2006?
Provide a short and direct response. -4.75e+09. What is the difference between the Imports (in Local Currency Unit) of Georgia in 2004 and the Imports (in Local Currency Unit) of Turkmenistan in 2006?
Make the answer very short. -3.04e+09. What is the difference between the Imports (in Local Currency Unit) in Australia in 2004 and the Imports (in Local Currency Unit) in Bahamas in 2007?
Provide a short and direct response. 1.65e+11. What is the difference between the Imports (in Local Currency Unit) of Australia in 2004 and the Imports (in Local Currency Unit) of Georgia in 2007?
Offer a terse response. 1.60e+11. What is the difference between the Imports (in Local Currency Unit) in Australia in 2004 and the Imports (in Local Currency Unit) in Turkmenistan in 2007?
Ensure brevity in your answer.  1.59e+11. What is the difference between the Imports (in Local Currency Unit) in Bahamas in 2004 and the Imports (in Local Currency Unit) in Georgia in 2007?
Ensure brevity in your answer.  -6.83e+09. What is the difference between the Imports (in Local Currency Unit) of Bahamas in 2004 and the Imports (in Local Currency Unit) of Turkmenistan in 2007?
Make the answer very short. -7.43e+09. What is the difference between the Imports (in Local Currency Unit) of Georgia in 2004 and the Imports (in Local Currency Unit) of Turkmenistan in 2007?
Offer a very short reply. -5.72e+09. What is the difference between the Imports (in Local Currency Unit) in Australia in 2004 and the Imports (in Local Currency Unit) in Bahamas in 2008?
Offer a very short reply. 1.65e+11. What is the difference between the Imports (in Local Currency Unit) in Australia in 2004 and the Imports (in Local Currency Unit) in Georgia in 2008?
Offer a terse response. 1.59e+11. What is the difference between the Imports (in Local Currency Unit) of Australia in 2004 and the Imports (in Local Currency Unit) of Turkmenistan in 2008?
Offer a terse response. 1.50e+11. What is the difference between the Imports (in Local Currency Unit) of Bahamas in 2004 and the Imports (in Local Currency Unit) of Georgia in 2008?
Give a very brief answer. -8.12e+09. What is the difference between the Imports (in Local Currency Unit) of Bahamas in 2004 and the Imports (in Local Currency Unit) of Turkmenistan in 2008?
Provide a short and direct response. -1.70e+1. What is the difference between the Imports (in Local Currency Unit) of Georgia in 2004 and the Imports (in Local Currency Unit) of Turkmenistan in 2008?
Make the answer very short. -1.52e+1. What is the difference between the Imports (in Local Currency Unit) of Australia in 2005 and the Imports (in Local Currency Unit) of Bahamas in 2006?
Provide a succinct answer. 1.87e+11. What is the difference between the Imports (in Local Currency Unit) of Australia in 2005 and the Imports (in Local Currency Unit) of Georgia in 2006?
Your answer should be compact. 1.84e+11. What is the difference between the Imports (in Local Currency Unit) in Australia in 2005 and the Imports (in Local Currency Unit) in Turkmenistan in 2006?
Keep it short and to the point. 1.84e+11. What is the difference between the Imports (in Local Currency Unit) in Bahamas in 2005 and the Imports (in Local Currency Unit) in Georgia in 2006?
Your answer should be very brief. -4.16e+09. What is the difference between the Imports (in Local Currency Unit) in Bahamas in 2005 and the Imports (in Local Currency Unit) in Turkmenistan in 2006?
Provide a short and direct response. -4.07e+09. What is the difference between the Imports (in Local Currency Unit) of Georgia in 2005 and the Imports (in Local Currency Unit) of Turkmenistan in 2006?
Your answer should be compact. -1.78e+09. What is the difference between the Imports (in Local Currency Unit) in Australia in 2005 and the Imports (in Local Currency Unit) in Bahamas in 2007?
Your answer should be compact. 1.87e+11. What is the difference between the Imports (in Local Currency Unit) in Australia in 2005 and the Imports (in Local Currency Unit) in Georgia in 2007?
Ensure brevity in your answer.  1.82e+11. What is the difference between the Imports (in Local Currency Unit) of Australia in 2005 and the Imports (in Local Currency Unit) of Turkmenistan in 2007?
Provide a short and direct response. 1.81e+11. What is the difference between the Imports (in Local Currency Unit) of Bahamas in 2005 and the Imports (in Local Currency Unit) of Georgia in 2007?
Provide a succinct answer. -6.15e+09. What is the difference between the Imports (in Local Currency Unit) of Bahamas in 2005 and the Imports (in Local Currency Unit) of Turkmenistan in 2007?
Your response must be concise. -6.75e+09. What is the difference between the Imports (in Local Currency Unit) of Georgia in 2005 and the Imports (in Local Currency Unit) of Turkmenistan in 2007?
Your answer should be compact. -4.46e+09. What is the difference between the Imports (in Local Currency Unit) of Australia in 2005 and the Imports (in Local Currency Unit) of Bahamas in 2008?
Provide a succinct answer. 1.87e+11. What is the difference between the Imports (in Local Currency Unit) in Australia in 2005 and the Imports (in Local Currency Unit) in Georgia in 2008?
Your response must be concise. 1.81e+11. What is the difference between the Imports (in Local Currency Unit) in Australia in 2005 and the Imports (in Local Currency Unit) in Turkmenistan in 2008?
Provide a short and direct response. 1.72e+11. What is the difference between the Imports (in Local Currency Unit) of Bahamas in 2005 and the Imports (in Local Currency Unit) of Georgia in 2008?
Your answer should be very brief. -7.44e+09. What is the difference between the Imports (in Local Currency Unit) in Bahamas in 2005 and the Imports (in Local Currency Unit) in Turkmenistan in 2008?
Keep it short and to the point. -1.63e+1. What is the difference between the Imports (in Local Currency Unit) in Georgia in 2005 and the Imports (in Local Currency Unit) in Turkmenistan in 2008?
Offer a very short reply. -1.40e+1. What is the difference between the Imports (in Local Currency Unit) of Australia in 2006 and the Imports (in Local Currency Unit) of Bahamas in 2007?
Your response must be concise. 2.09e+11. What is the difference between the Imports (in Local Currency Unit) in Australia in 2006 and the Imports (in Local Currency Unit) in Georgia in 2007?
Offer a terse response. 2.04e+11. What is the difference between the Imports (in Local Currency Unit) of Australia in 2006 and the Imports (in Local Currency Unit) of Turkmenistan in 2007?
Your response must be concise. 2.03e+11. What is the difference between the Imports (in Local Currency Unit) of Bahamas in 2006 and the Imports (in Local Currency Unit) of Georgia in 2007?
Offer a terse response. -5.43e+09. What is the difference between the Imports (in Local Currency Unit) of Bahamas in 2006 and the Imports (in Local Currency Unit) of Turkmenistan in 2007?
Your response must be concise. -6.03e+09. What is the difference between the Imports (in Local Currency Unit) of Georgia in 2006 and the Imports (in Local Currency Unit) of Turkmenistan in 2007?
Provide a succinct answer. -2.59e+09. What is the difference between the Imports (in Local Currency Unit) of Australia in 2006 and the Imports (in Local Currency Unit) of Bahamas in 2008?
Provide a short and direct response. 2.09e+11. What is the difference between the Imports (in Local Currency Unit) in Australia in 2006 and the Imports (in Local Currency Unit) in Georgia in 2008?
Your response must be concise. 2.02e+11. What is the difference between the Imports (in Local Currency Unit) of Australia in 2006 and the Imports (in Local Currency Unit) of Turkmenistan in 2008?
Make the answer very short. 1.94e+11. What is the difference between the Imports (in Local Currency Unit) of Bahamas in 2006 and the Imports (in Local Currency Unit) of Georgia in 2008?
Give a very brief answer. -6.72e+09. What is the difference between the Imports (in Local Currency Unit) of Bahamas in 2006 and the Imports (in Local Currency Unit) of Turkmenistan in 2008?
Give a very brief answer. -1.56e+1. What is the difference between the Imports (in Local Currency Unit) in Georgia in 2006 and the Imports (in Local Currency Unit) in Turkmenistan in 2008?
Your answer should be compact. -1.21e+1. What is the difference between the Imports (in Local Currency Unit) of Australia in 2007 and the Imports (in Local Currency Unit) of Bahamas in 2008?
Give a very brief answer. 2.29e+11. What is the difference between the Imports (in Local Currency Unit) in Australia in 2007 and the Imports (in Local Currency Unit) in Georgia in 2008?
Make the answer very short. 2.23e+11. What is the difference between the Imports (in Local Currency Unit) in Australia in 2007 and the Imports (in Local Currency Unit) in Turkmenistan in 2008?
Provide a succinct answer. 2.14e+11. What is the difference between the Imports (in Local Currency Unit) of Bahamas in 2007 and the Imports (in Local Currency Unit) of Georgia in 2008?
Give a very brief answer. -6.65e+09. What is the difference between the Imports (in Local Currency Unit) in Bahamas in 2007 and the Imports (in Local Currency Unit) in Turkmenistan in 2008?
Provide a short and direct response. -1.55e+1. What is the difference between the Imports (in Local Currency Unit) in Georgia in 2007 and the Imports (in Local Currency Unit) in Turkmenistan in 2008?
Provide a succinct answer. -1.01e+1. What is the average Imports (in Local Currency Unit) in Australia per year?
Offer a terse response. 1.94e+11. What is the average Imports (in Local Currency Unit) of Bahamas per year?
Offer a terse response. 3.54e+09. What is the average Imports (in Local Currency Unit) of Georgia per year?
Offer a terse response. 6.16e+09. What is the average Imports (in Local Currency Unit) in Turkmenistan per year?
Offer a terse response. 9.08e+09. In the year 2001, what is the difference between the Imports (in Local Currency Unit) in Australia and Imports (in Local Currency Unit) in Bahamas?
Provide a succinct answer. 1.52e+11. In the year 2001, what is the difference between the Imports (in Local Currency Unit) of Australia and Imports (in Local Currency Unit) of Georgia?
Offer a terse response. 1.52e+11. In the year 2001, what is the difference between the Imports (in Local Currency Unit) of Australia and Imports (in Local Currency Unit) of Turkmenistan?
Your answer should be very brief. 1.49e+11. In the year 2001, what is the difference between the Imports (in Local Currency Unit) of Bahamas and Imports (in Local Currency Unit) of Georgia?
Give a very brief answer. 2.26e+08. In the year 2001, what is the difference between the Imports (in Local Currency Unit) of Bahamas and Imports (in Local Currency Unit) of Turkmenistan?
Ensure brevity in your answer.  -2.72e+09. In the year 2001, what is the difference between the Imports (in Local Currency Unit) of Georgia and Imports (in Local Currency Unit) of Turkmenistan?
Provide a short and direct response. -2.95e+09. In the year 2002, what is the difference between the Imports (in Local Currency Unit) of Australia and Imports (in Local Currency Unit) of Bahamas?
Your response must be concise. 1.53e+11. In the year 2002, what is the difference between the Imports (in Local Currency Unit) of Australia and Imports (in Local Currency Unit) of Georgia?
Ensure brevity in your answer.  1.52e+11. In the year 2002, what is the difference between the Imports (in Local Currency Unit) of Australia and Imports (in Local Currency Unit) of Turkmenistan?
Keep it short and to the point. 1.51e+11. In the year 2002, what is the difference between the Imports (in Local Currency Unit) of Bahamas and Imports (in Local Currency Unit) of Georgia?
Your response must be concise. -4.89e+08. In the year 2002, what is the difference between the Imports (in Local Currency Unit) of Bahamas and Imports (in Local Currency Unit) of Turkmenistan?
Give a very brief answer. -2.16e+09. In the year 2002, what is the difference between the Imports (in Local Currency Unit) in Georgia and Imports (in Local Currency Unit) in Turkmenistan?
Provide a succinct answer. -1.67e+09. In the year 2003, what is the difference between the Imports (in Local Currency Unit) in Australia and Imports (in Local Currency Unit) in Bahamas?
Offer a terse response. 1.66e+11. In the year 2003, what is the difference between the Imports (in Local Currency Unit) in Australia and Imports (in Local Currency Unit) in Georgia?
Offer a terse response. 1.65e+11. In the year 2003, what is the difference between the Imports (in Local Currency Unit) of Australia and Imports (in Local Currency Unit) of Turkmenistan?
Offer a very short reply. 1.62e+11. In the year 2003, what is the difference between the Imports (in Local Currency Unit) of Bahamas and Imports (in Local Currency Unit) of Georgia?
Your answer should be very brief. -1.22e+09. In the year 2003, what is the difference between the Imports (in Local Currency Unit) of Bahamas and Imports (in Local Currency Unit) of Turkmenistan?
Your response must be concise. -3.97e+09. In the year 2003, what is the difference between the Imports (in Local Currency Unit) of Georgia and Imports (in Local Currency Unit) of Turkmenistan?
Your answer should be compact. -2.75e+09. In the year 2004, what is the difference between the Imports (in Local Currency Unit) of Australia and Imports (in Local Currency Unit) of Bahamas?
Offer a terse response. 1.67e+11. In the year 2004, what is the difference between the Imports (in Local Currency Unit) of Australia and Imports (in Local Currency Unit) of Georgia?
Keep it short and to the point. 1.65e+11. In the year 2004, what is the difference between the Imports (in Local Currency Unit) of Australia and Imports (in Local Currency Unit) of Turkmenistan?
Give a very brief answer. 1.61e+11. In the year 2004, what is the difference between the Imports (in Local Currency Unit) in Bahamas and Imports (in Local Currency Unit) in Georgia?
Give a very brief answer. -1.71e+09. In the year 2004, what is the difference between the Imports (in Local Currency Unit) of Bahamas and Imports (in Local Currency Unit) of Turkmenistan?
Ensure brevity in your answer.  -5.77e+09. In the year 2004, what is the difference between the Imports (in Local Currency Unit) of Georgia and Imports (in Local Currency Unit) of Turkmenistan?
Your answer should be compact. -4.06e+09. In the year 2005, what is the difference between the Imports (in Local Currency Unit) in Australia and Imports (in Local Currency Unit) in Bahamas?
Make the answer very short. 1.88e+11. In the year 2005, what is the difference between the Imports (in Local Currency Unit) in Australia and Imports (in Local Currency Unit) in Georgia?
Give a very brief answer. 1.86e+11. In the year 2005, what is the difference between the Imports (in Local Currency Unit) of Australia and Imports (in Local Currency Unit) of Turkmenistan?
Keep it short and to the point. 1.83e+11. In the year 2005, what is the difference between the Imports (in Local Currency Unit) in Bahamas and Imports (in Local Currency Unit) in Georgia?
Keep it short and to the point. -2.29e+09. In the year 2005, what is the difference between the Imports (in Local Currency Unit) in Bahamas and Imports (in Local Currency Unit) in Turkmenistan?
Offer a very short reply. -4.83e+09. In the year 2005, what is the difference between the Imports (in Local Currency Unit) of Georgia and Imports (in Local Currency Unit) of Turkmenistan?
Provide a succinct answer. -2.54e+09. In the year 2006, what is the difference between the Imports (in Local Currency Unit) in Australia and Imports (in Local Currency Unit) in Bahamas?
Provide a succinct answer. 2.09e+11. In the year 2006, what is the difference between the Imports (in Local Currency Unit) of Australia and Imports (in Local Currency Unit) of Georgia?
Keep it short and to the point. 2.06e+11. In the year 2006, what is the difference between the Imports (in Local Currency Unit) of Australia and Imports (in Local Currency Unit) of Turkmenistan?
Your answer should be compact. 2.06e+11. In the year 2006, what is the difference between the Imports (in Local Currency Unit) of Bahamas and Imports (in Local Currency Unit) of Georgia?
Keep it short and to the point. -3.45e+09. In the year 2006, what is the difference between the Imports (in Local Currency Unit) in Bahamas and Imports (in Local Currency Unit) in Turkmenistan?
Keep it short and to the point. -3.35e+09. In the year 2006, what is the difference between the Imports (in Local Currency Unit) of Georgia and Imports (in Local Currency Unit) of Turkmenistan?
Ensure brevity in your answer.  9.24e+07. In the year 2007, what is the difference between the Imports (in Local Currency Unit) of Australia and Imports (in Local Currency Unit) of Bahamas?
Provide a short and direct response. 2.29e+11. In the year 2007, what is the difference between the Imports (in Local Currency Unit) in Australia and Imports (in Local Currency Unit) in Georgia?
Your answer should be very brief. 2.24e+11. In the year 2007, what is the difference between the Imports (in Local Currency Unit) in Australia and Imports (in Local Currency Unit) in Turkmenistan?
Give a very brief answer. 2.23e+11. In the year 2007, what is the difference between the Imports (in Local Currency Unit) in Bahamas and Imports (in Local Currency Unit) in Georgia?
Your answer should be very brief. -5.36e+09. In the year 2007, what is the difference between the Imports (in Local Currency Unit) of Bahamas and Imports (in Local Currency Unit) of Turkmenistan?
Your answer should be very brief. -5.96e+09. In the year 2007, what is the difference between the Imports (in Local Currency Unit) of Georgia and Imports (in Local Currency Unit) of Turkmenistan?
Ensure brevity in your answer.  -6.01e+08. In the year 2008, what is the difference between the Imports (in Local Currency Unit) in Australia and Imports (in Local Currency Unit) in Bahamas?
Offer a terse response. 2.59e+11. In the year 2008, what is the difference between the Imports (in Local Currency Unit) in Australia and Imports (in Local Currency Unit) in Georgia?
Offer a very short reply. 2.52e+11. In the year 2008, what is the difference between the Imports (in Local Currency Unit) in Australia and Imports (in Local Currency Unit) in Turkmenistan?
Your answer should be very brief. 2.43e+11. In the year 2008, what is the difference between the Imports (in Local Currency Unit) of Bahamas and Imports (in Local Currency Unit) of Georgia?
Provide a short and direct response. -6.69e+09. In the year 2008, what is the difference between the Imports (in Local Currency Unit) of Bahamas and Imports (in Local Currency Unit) of Turkmenistan?
Offer a terse response. -1.55e+1. In the year 2008, what is the difference between the Imports (in Local Currency Unit) of Georgia and Imports (in Local Currency Unit) of Turkmenistan?
Provide a short and direct response. -8.83e+09. What is the ratio of the Imports (in Local Currency Unit) in Bahamas in 2001 to that in 2002?
Keep it short and to the point. 1.06. What is the ratio of the Imports (in Local Currency Unit) of Georgia in 2001 to that in 2002?
Give a very brief answer. 0.82. What is the ratio of the Imports (in Local Currency Unit) in Turkmenistan in 2001 to that in 2002?
Ensure brevity in your answer.  1.15. What is the ratio of the Imports (in Local Currency Unit) in Australia in 2001 to that in 2003?
Offer a terse response. 0.92. What is the ratio of the Imports (in Local Currency Unit) of Bahamas in 2001 to that in 2003?
Offer a very short reply. 1.02. What is the ratio of the Imports (in Local Currency Unit) in Georgia in 2001 to that in 2003?
Provide a succinct answer. 0.65. What is the ratio of the Imports (in Local Currency Unit) in Turkmenistan in 2001 to that in 2003?
Give a very brief answer. 0.82. What is the ratio of the Imports (in Local Currency Unit) in Australia in 2001 to that in 2004?
Offer a terse response. 0.91. What is the ratio of the Imports (in Local Currency Unit) in Bahamas in 2001 to that in 2004?
Provide a short and direct response. 0.93. What is the ratio of the Imports (in Local Currency Unit) in Georgia in 2001 to that in 2004?
Provide a succinct answer. 0.55. What is the ratio of the Imports (in Local Currency Unit) in Turkmenistan in 2001 to that in 2004?
Keep it short and to the point. 0.63. What is the ratio of the Imports (in Local Currency Unit) of Australia in 2001 to that in 2005?
Offer a terse response. 0.81. What is the ratio of the Imports (in Local Currency Unit) of Bahamas in 2001 to that in 2005?
Keep it short and to the point. 0.76. What is the ratio of the Imports (in Local Currency Unit) in Georgia in 2001 to that in 2005?
Keep it short and to the point. 0.43. What is the ratio of the Imports (in Local Currency Unit) in Turkmenistan in 2001 to that in 2005?
Make the answer very short. 0.65. What is the ratio of the Imports (in Local Currency Unit) of Australia in 2001 to that in 2006?
Keep it short and to the point. 0.73. What is the ratio of the Imports (in Local Currency Unit) of Bahamas in 2001 to that in 2006?
Give a very brief answer. 0.64. What is the ratio of the Imports (in Local Currency Unit) of Georgia in 2001 to that in 2006?
Offer a terse response. 0.33. What is the ratio of the Imports (in Local Currency Unit) in Turkmenistan in 2001 to that in 2006?
Keep it short and to the point. 0.71. What is the ratio of the Imports (in Local Currency Unit) in Australia in 2001 to that in 2007?
Make the answer very short. 0.66. What is the ratio of the Imports (in Local Currency Unit) in Bahamas in 2001 to that in 2007?
Your response must be concise. 0.63. What is the ratio of the Imports (in Local Currency Unit) of Georgia in 2001 to that in 2007?
Give a very brief answer. 0.26. What is the ratio of the Imports (in Local Currency Unit) in Turkmenistan in 2001 to that in 2007?
Offer a terse response. 0.53. What is the ratio of the Imports (in Local Currency Unit) in Australia in 2001 to that in 2008?
Your response must be concise. 0.59. What is the ratio of the Imports (in Local Currency Unit) in Bahamas in 2001 to that in 2008?
Offer a very short reply. 0.63. What is the ratio of the Imports (in Local Currency Unit) of Georgia in 2001 to that in 2008?
Offer a terse response. 0.23. What is the ratio of the Imports (in Local Currency Unit) of Turkmenistan in 2001 to that in 2008?
Offer a terse response. 0.28. What is the ratio of the Imports (in Local Currency Unit) of Australia in 2002 to that in 2003?
Make the answer very short. 0.92. What is the ratio of the Imports (in Local Currency Unit) of Bahamas in 2002 to that in 2003?
Your answer should be compact. 0.97. What is the ratio of the Imports (in Local Currency Unit) of Georgia in 2002 to that in 2003?
Your response must be concise. 0.8. What is the ratio of the Imports (in Local Currency Unit) in Turkmenistan in 2002 to that in 2003?
Make the answer very short. 0.72. What is the ratio of the Imports (in Local Currency Unit) in Australia in 2002 to that in 2004?
Provide a short and direct response. 0.92. What is the ratio of the Imports (in Local Currency Unit) in Bahamas in 2002 to that in 2004?
Provide a succinct answer. 0.89. What is the ratio of the Imports (in Local Currency Unit) in Georgia in 2002 to that in 2004?
Offer a very short reply. 0.67. What is the ratio of the Imports (in Local Currency Unit) in Turkmenistan in 2002 to that in 2004?
Offer a very short reply. 0.55. What is the ratio of the Imports (in Local Currency Unit) of Australia in 2002 to that in 2005?
Your response must be concise. 0.81. What is the ratio of the Imports (in Local Currency Unit) of Bahamas in 2002 to that in 2005?
Provide a succinct answer. 0.72. What is the ratio of the Imports (in Local Currency Unit) in Georgia in 2002 to that in 2005?
Ensure brevity in your answer.  0.53. What is the ratio of the Imports (in Local Currency Unit) in Turkmenistan in 2002 to that in 2005?
Your answer should be very brief. 0.57. What is the ratio of the Imports (in Local Currency Unit) of Australia in 2002 to that in 2006?
Your answer should be compact. 0.73. What is the ratio of the Imports (in Local Currency Unit) in Bahamas in 2002 to that in 2006?
Give a very brief answer. 0.6. What is the ratio of the Imports (in Local Currency Unit) of Georgia in 2002 to that in 2006?
Provide a short and direct response. 0.4. What is the ratio of the Imports (in Local Currency Unit) of Turkmenistan in 2002 to that in 2006?
Offer a terse response. 0.62. What is the ratio of the Imports (in Local Currency Unit) in Australia in 2002 to that in 2007?
Offer a very short reply. 0.67. What is the ratio of the Imports (in Local Currency Unit) of Bahamas in 2002 to that in 2007?
Provide a short and direct response. 0.6. What is the ratio of the Imports (in Local Currency Unit) in Georgia in 2002 to that in 2007?
Your answer should be compact. 0.32. What is the ratio of the Imports (in Local Currency Unit) in Turkmenistan in 2002 to that in 2007?
Your answer should be compact. 0.46. What is the ratio of the Imports (in Local Currency Unit) of Australia in 2002 to that in 2008?
Your answer should be compact. 0.59. What is the ratio of the Imports (in Local Currency Unit) of Bahamas in 2002 to that in 2008?
Your answer should be very brief. 0.6. What is the ratio of the Imports (in Local Currency Unit) of Georgia in 2002 to that in 2008?
Ensure brevity in your answer.  0.28. What is the ratio of the Imports (in Local Currency Unit) of Turkmenistan in 2002 to that in 2008?
Make the answer very short. 0.24. What is the ratio of the Imports (in Local Currency Unit) of Bahamas in 2003 to that in 2004?
Keep it short and to the point. 0.91. What is the ratio of the Imports (in Local Currency Unit) in Georgia in 2003 to that in 2004?
Offer a terse response. 0.84. What is the ratio of the Imports (in Local Currency Unit) in Turkmenistan in 2003 to that in 2004?
Provide a succinct answer. 0.77. What is the ratio of the Imports (in Local Currency Unit) in Australia in 2003 to that in 2005?
Make the answer very short. 0.88. What is the ratio of the Imports (in Local Currency Unit) of Bahamas in 2003 to that in 2005?
Offer a very short reply. 0.75. What is the ratio of the Imports (in Local Currency Unit) in Georgia in 2003 to that in 2005?
Keep it short and to the point. 0.66. What is the ratio of the Imports (in Local Currency Unit) in Turkmenistan in 2003 to that in 2005?
Give a very brief answer. 0.79. What is the ratio of the Imports (in Local Currency Unit) of Australia in 2003 to that in 2006?
Offer a very short reply. 0.79. What is the ratio of the Imports (in Local Currency Unit) of Bahamas in 2003 to that in 2006?
Offer a very short reply. 0.62. What is the ratio of the Imports (in Local Currency Unit) in Georgia in 2003 to that in 2006?
Offer a terse response. 0.51. What is the ratio of the Imports (in Local Currency Unit) of Turkmenistan in 2003 to that in 2006?
Keep it short and to the point. 0.87. What is the ratio of the Imports (in Local Currency Unit) in Australia in 2003 to that in 2007?
Provide a short and direct response. 0.72. What is the ratio of the Imports (in Local Currency Unit) of Bahamas in 2003 to that in 2007?
Keep it short and to the point. 0.61. What is the ratio of the Imports (in Local Currency Unit) of Georgia in 2003 to that in 2007?
Give a very brief answer. 0.4. What is the ratio of the Imports (in Local Currency Unit) of Turkmenistan in 2003 to that in 2007?
Make the answer very short. 0.64. What is the ratio of the Imports (in Local Currency Unit) of Australia in 2003 to that in 2008?
Provide a short and direct response. 0.64. What is the ratio of the Imports (in Local Currency Unit) in Bahamas in 2003 to that in 2008?
Keep it short and to the point. 0.62. What is the ratio of the Imports (in Local Currency Unit) of Georgia in 2003 to that in 2008?
Provide a short and direct response. 0.36. What is the ratio of the Imports (in Local Currency Unit) in Turkmenistan in 2003 to that in 2008?
Offer a very short reply. 0.34. What is the ratio of the Imports (in Local Currency Unit) of Australia in 2004 to that in 2005?
Offer a very short reply. 0.89. What is the ratio of the Imports (in Local Currency Unit) of Bahamas in 2004 to that in 2005?
Keep it short and to the point. 0.82. What is the ratio of the Imports (in Local Currency Unit) in Georgia in 2004 to that in 2005?
Provide a short and direct response. 0.79. What is the ratio of the Imports (in Local Currency Unit) in Turkmenistan in 2004 to that in 2005?
Your answer should be very brief. 1.03. What is the ratio of the Imports (in Local Currency Unit) of Australia in 2004 to that in 2006?
Your response must be concise. 0.8. What is the ratio of the Imports (in Local Currency Unit) in Bahamas in 2004 to that in 2006?
Provide a short and direct response. 0.68. What is the ratio of the Imports (in Local Currency Unit) in Georgia in 2004 to that in 2006?
Make the answer very short. 0.6. What is the ratio of the Imports (in Local Currency Unit) of Turkmenistan in 2004 to that in 2006?
Make the answer very short. 1.13. What is the ratio of the Imports (in Local Currency Unit) in Australia in 2004 to that in 2007?
Your answer should be compact. 0.73. What is the ratio of the Imports (in Local Currency Unit) of Bahamas in 2004 to that in 2007?
Your answer should be very brief. 0.67. What is the ratio of the Imports (in Local Currency Unit) of Georgia in 2004 to that in 2007?
Give a very brief answer. 0.48. What is the ratio of the Imports (in Local Currency Unit) of Turkmenistan in 2004 to that in 2007?
Offer a terse response. 0.84. What is the ratio of the Imports (in Local Currency Unit) in Australia in 2004 to that in 2008?
Your answer should be compact. 0.64. What is the ratio of the Imports (in Local Currency Unit) of Bahamas in 2004 to that in 2008?
Offer a terse response. 0.68. What is the ratio of the Imports (in Local Currency Unit) in Georgia in 2004 to that in 2008?
Make the answer very short. 0.42. What is the ratio of the Imports (in Local Currency Unit) of Turkmenistan in 2004 to that in 2008?
Your answer should be compact. 0.44. What is the ratio of the Imports (in Local Currency Unit) of Australia in 2005 to that in 2006?
Offer a very short reply. 0.9. What is the ratio of the Imports (in Local Currency Unit) in Bahamas in 2005 to that in 2006?
Provide a short and direct response. 0.84. What is the ratio of the Imports (in Local Currency Unit) in Georgia in 2005 to that in 2006?
Give a very brief answer. 0.76. What is the ratio of the Imports (in Local Currency Unit) of Turkmenistan in 2005 to that in 2006?
Offer a terse response. 1.1. What is the ratio of the Imports (in Local Currency Unit) in Australia in 2005 to that in 2007?
Keep it short and to the point. 0.82. What is the ratio of the Imports (in Local Currency Unit) of Bahamas in 2005 to that in 2007?
Your answer should be very brief. 0.82. What is the ratio of the Imports (in Local Currency Unit) of Georgia in 2005 to that in 2007?
Give a very brief answer. 0.61. What is the ratio of the Imports (in Local Currency Unit) of Turkmenistan in 2005 to that in 2007?
Ensure brevity in your answer.  0.82. What is the ratio of the Imports (in Local Currency Unit) in Australia in 2005 to that in 2008?
Provide a short and direct response. 0.73. What is the ratio of the Imports (in Local Currency Unit) of Bahamas in 2005 to that in 2008?
Provide a succinct answer. 0.83. What is the ratio of the Imports (in Local Currency Unit) in Georgia in 2005 to that in 2008?
Give a very brief answer. 0.54. What is the ratio of the Imports (in Local Currency Unit) in Turkmenistan in 2005 to that in 2008?
Give a very brief answer. 0.43. What is the ratio of the Imports (in Local Currency Unit) of Australia in 2006 to that in 2007?
Your answer should be very brief. 0.91. What is the ratio of the Imports (in Local Currency Unit) of Bahamas in 2006 to that in 2007?
Your answer should be very brief. 0.98. What is the ratio of the Imports (in Local Currency Unit) of Georgia in 2006 to that in 2007?
Your response must be concise. 0.8. What is the ratio of the Imports (in Local Currency Unit) of Turkmenistan in 2006 to that in 2007?
Your response must be concise. 0.74. What is the ratio of the Imports (in Local Currency Unit) of Australia in 2006 to that in 2008?
Offer a terse response. 0.81. What is the ratio of the Imports (in Local Currency Unit) of Bahamas in 2006 to that in 2008?
Make the answer very short. 0.99. What is the ratio of the Imports (in Local Currency Unit) in Georgia in 2006 to that in 2008?
Ensure brevity in your answer.  0.71. What is the ratio of the Imports (in Local Currency Unit) in Turkmenistan in 2006 to that in 2008?
Provide a succinct answer. 0.39. What is the ratio of the Imports (in Local Currency Unit) of Australia in 2007 to that in 2008?
Provide a short and direct response. 0.89. What is the ratio of the Imports (in Local Currency Unit) in Bahamas in 2007 to that in 2008?
Provide a succinct answer. 1.01. What is the ratio of the Imports (in Local Currency Unit) in Georgia in 2007 to that in 2008?
Your response must be concise. 0.88. What is the ratio of the Imports (in Local Currency Unit) in Turkmenistan in 2007 to that in 2008?
Give a very brief answer. 0.52. What is the difference between the highest and the second highest Imports (in Local Currency Unit) of Australia?
Make the answer very short. 2.97e+1. What is the difference between the highest and the second highest Imports (in Local Currency Unit) of Bahamas?
Provide a succinct answer. 3.76e+07. What is the difference between the highest and the second highest Imports (in Local Currency Unit) in Georgia?
Keep it short and to the point. 1.29e+09. What is the difference between the highest and the second highest Imports (in Local Currency Unit) in Turkmenistan?
Your answer should be compact. 9.52e+09. What is the difference between the highest and the lowest Imports (in Local Currency Unit) of Australia?
Keep it short and to the point. 1.08e+11. What is the difference between the highest and the lowest Imports (in Local Currency Unit) in Bahamas?
Your answer should be compact. 1.82e+09. What is the difference between the highest and the lowest Imports (in Local Currency Unit) in Georgia?
Provide a succinct answer. 8.55e+09. What is the difference between the highest and the lowest Imports (in Local Currency Unit) of Turkmenistan?
Provide a succinct answer. 1.51e+1. 